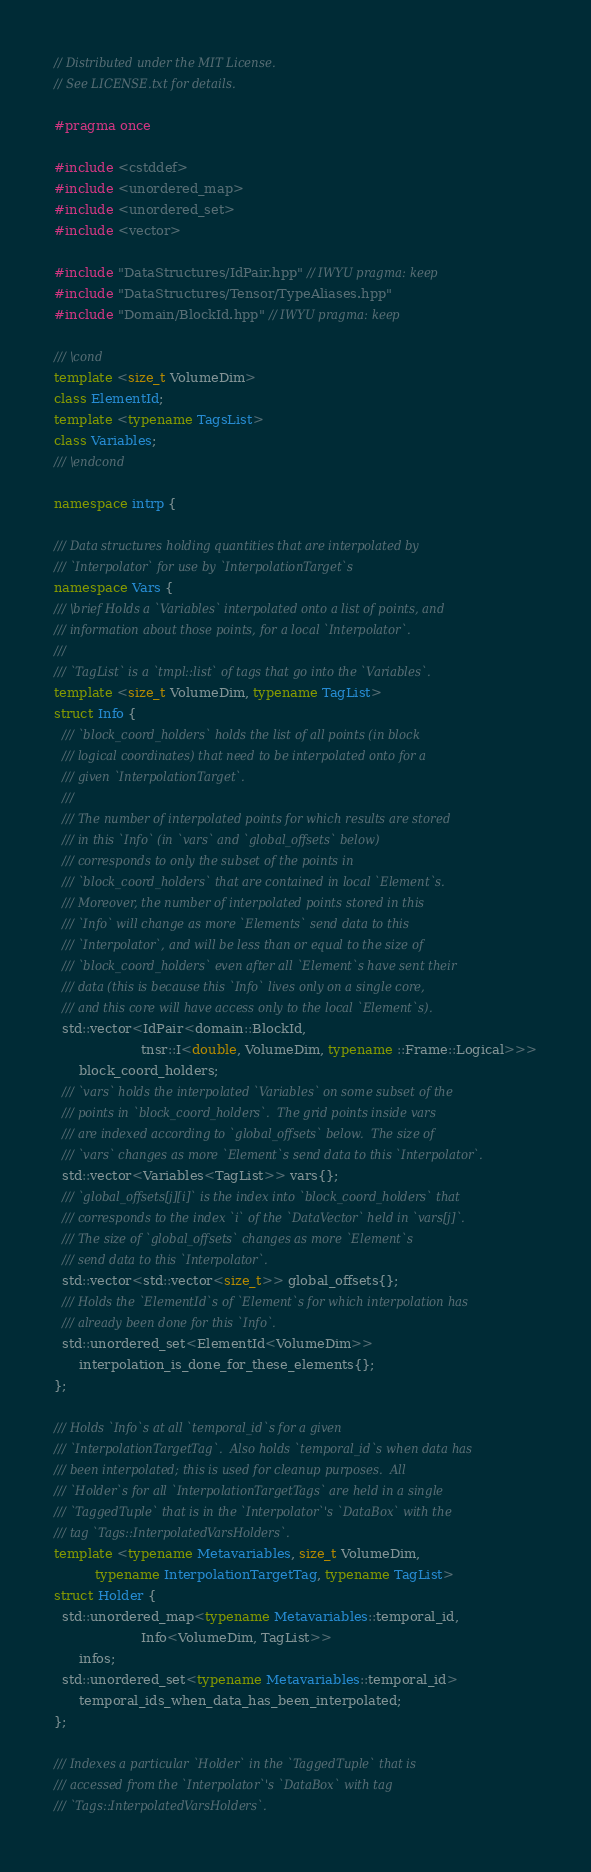Convert code to text. <code><loc_0><loc_0><loc_500><loc_500><_C++_>// Distributed under the MIT License.
// See LICENSE.txt for details.

#pragma once

#include <cstddef>
#include <unordered_map>
#include <unordered_set>
#include <vector>

#include "DataStructures/IdPair.hpp" // IWYU pragma: keep
#include "DataStructures/Tensor/TypeAliases.hpp"
#include "Domain/BlockId.hpp" // IWYU pragma: keep

/// \cond
template <size_t VolumeDim>
class ElementId;
template <typename TagsList>
class Variables;
/// \endcond

namespace intrp {

/// Data structures holding quantities that are interpolated by
/// `Interpolator` for use by `InterpolationTarget`s
namespace Vars {
/// \brief Holds a `Variables` interpolated onto a list of points, and
/// information about those points, for a local `Interpolator`.
///
/// `TagList` is a `tmpl::list` of tags that go into the `Variables`.
template <size_t VolumeDim, typename TagList>
struct Info {
  /// `block_coord_holders` holds the list of all points (in block
  /// logical coordinates) that need to be interpolated onto for a
  /// given `InterpolationTarget`.
  ///
  /// The number of interpolated points for which results are stored
  /// in this `Info` (in `vars` and `global_offsets` below)
  /// corresponds to only the subset of the points in
  /// `block_coord_holders` that are contained in local `Element`s.
  /// Moreover, the number of interpolated points stored in this
  /// `Info` will change as more `Elements` send data to this
  /// `Interpolator`, and will be less than or equal to the size of
  /// `block_coord_holders` even after all `Element`s have sent their
  /// data (this is because this `Info` lives only on a single core,
  /// and this core will have access only to the local `Element`s).
  std::vector<IdPair<domain::BlockId,
                     tnsr::I<double, VolumeDim, typename ::Frame::Logical>>>
      block_coord_holders;
  /// `vars` holds the interpolated `Variables` on some subset of the
  /// points in `block_coord_holders`.  The grid points inside vars
  /// are indexed according to `global_offsets` below.  The size of
  /// `vars` changes as more `Element`s send data to this `Interpolator`.
  std::vector<Variables<TagList>> vars{};
  /// `global_offsets[j][i]` is the index into `block_coord_holders` that
  /// corresponds to the index `i` of the `DataVector` held in `vars[j]`.
  /// The size of `global_offsets` changes as more `Element`s
  /// send data to this `Interpolator`.
  std::vector<std::vector<size_t>> global_offsets{};
  /// Holds the `ElementId`s of `Element`s for which interpolation has
  /// already been done for this `Info`.
  std::unordered_set<ElementId<VolumeDim>>
      interpolation_is_done_for_these_elements{};
};

/// Holds `Info`s at all `temporal_id`s for a given
/// `InterpolationTargetTag`.  Also holds `temporal_id`s when data has
/// been interpolated; this is used for cleanup purposes.  All
/// `Holder`s for all `InterpolationTargetTags` are held in a single
/// `TaggedTuple` that is in the `Interpolator`'s `DataBox` with the
/// tag `Tags::InterpolatedVarsHolders`.
template <typename Metavariables, size_t VolumeDim,
          typename InterpolationTargetTag, typename TagList>
struct Holder {
  std::unordered_map<typename Metavariables::temporal_id,
                     Info<VolumeDim, TagList>>
      infos;
  std::unordered_set<typename Metavariables::temporal_id>
      temporal_ids_when_data_has_been_interpolated;
};

/// Indexes a particular `Holder` in the `TaggedTuple` that is
/// accessed from the `Interpolator`'s `DataBox` with tag
/// `Tags::InterpolatedVarsHolders`.</code> 